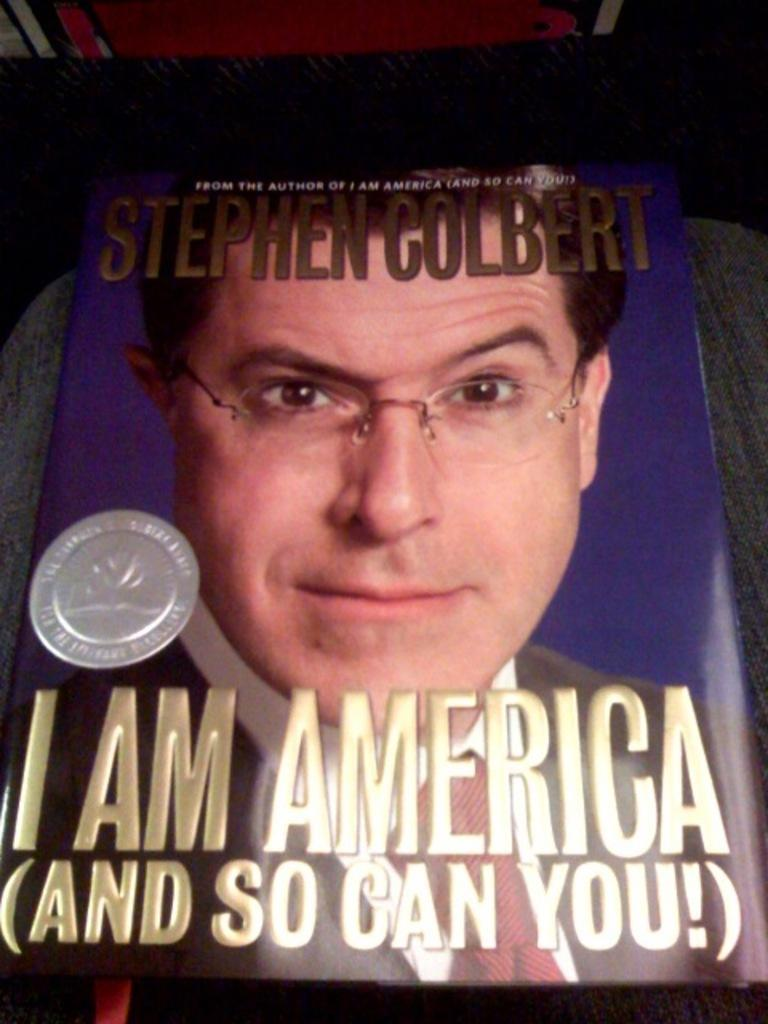What is the main object in the image? There is a book in the image. What is depicted on the book? The book has an image of a person wearing specs. Are there any words or text on the book? Yes, there is writing on the book. Where is the book located in the image? The book is on a surface. What color is the brick used to play volleyball in the image? There is no brick or volleyball present in the image. 